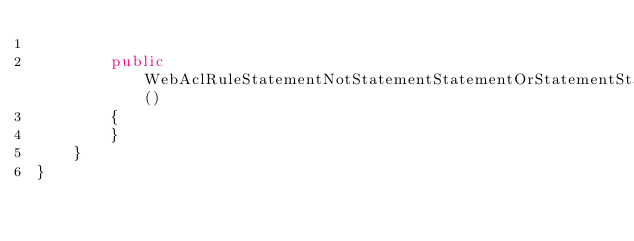<code> <loc_0><loc_0><loc_500><loc_500><_C#_>
        public WebAclRuleStatementNotStatementStatementOrStatementStatementNotStatementStatementGeoMatchStatementForwardedIpConfigGetArgs()
        {
        }
    }
}
</code> 